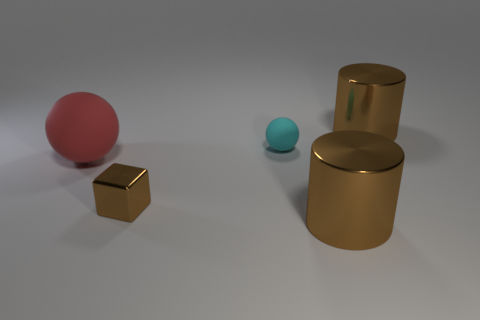Add 1 spheres. How many objects exist? 6 Subtract all blocks. How many objects are left? 4 Subtract 1 spheres. How many spheres are left? 1 Add 5 brown cylinders. How many brown cylinders exist? 7 Subtract 0 red cubes. How many objects are left? 5 Subtract all gray blocks. Subtract all blue cylinders. How many blocks are left? 1 Subtract all gray cubes. How many blue balls are left? 0 Subtract all cyan rubber objects. Subtract all shiny things. How many objects are left? 1 Add 2 red spheres. How many red spheres are left? 3 